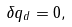<formula> <loc_0><loc_0><loc_500><loc_500>\delta q _ { d } = 0 ,</formula> 